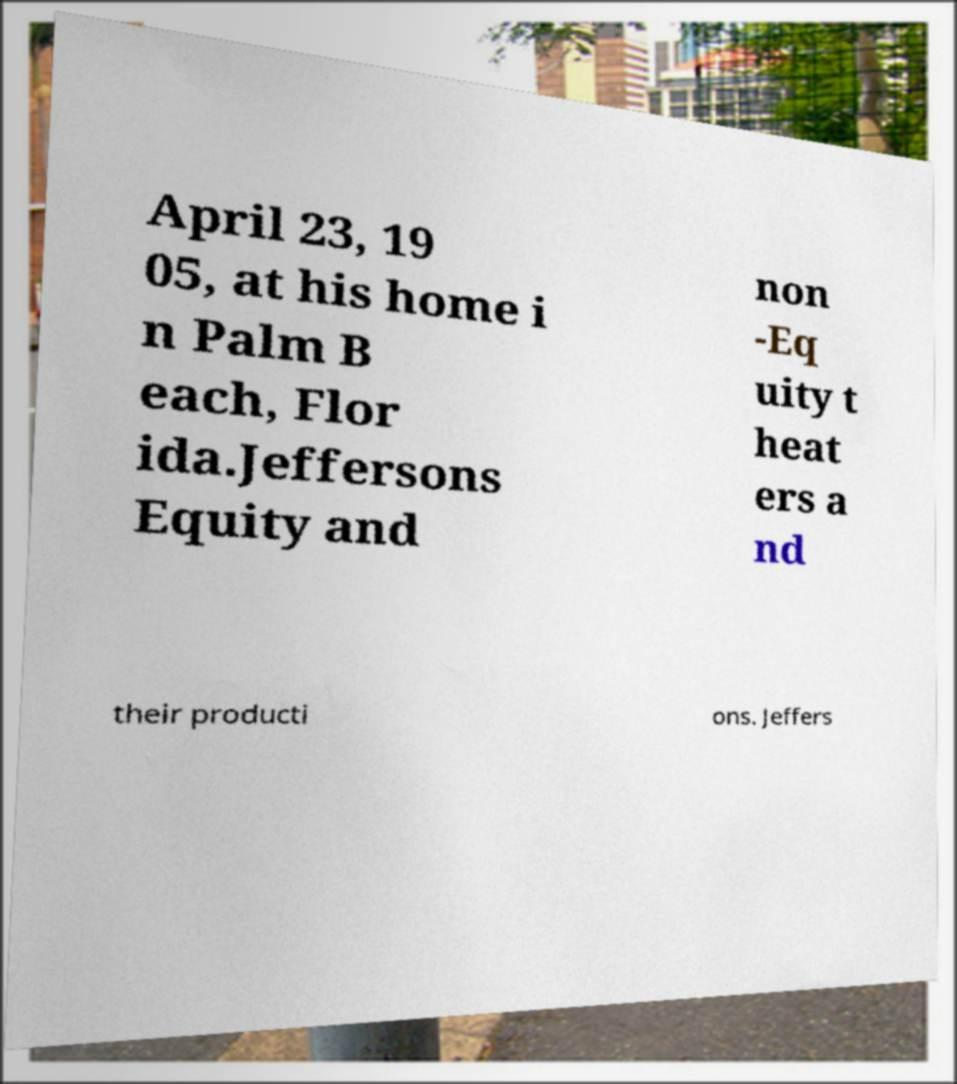For documentation purposes, I need the text within this image transcribed. Could you provide that? April 23, 19 05, at his home i n Palm B each, Flor ida.Jeffersons Equity and non -Eq uity t heat ers a nd their producti ons. Jeffers 